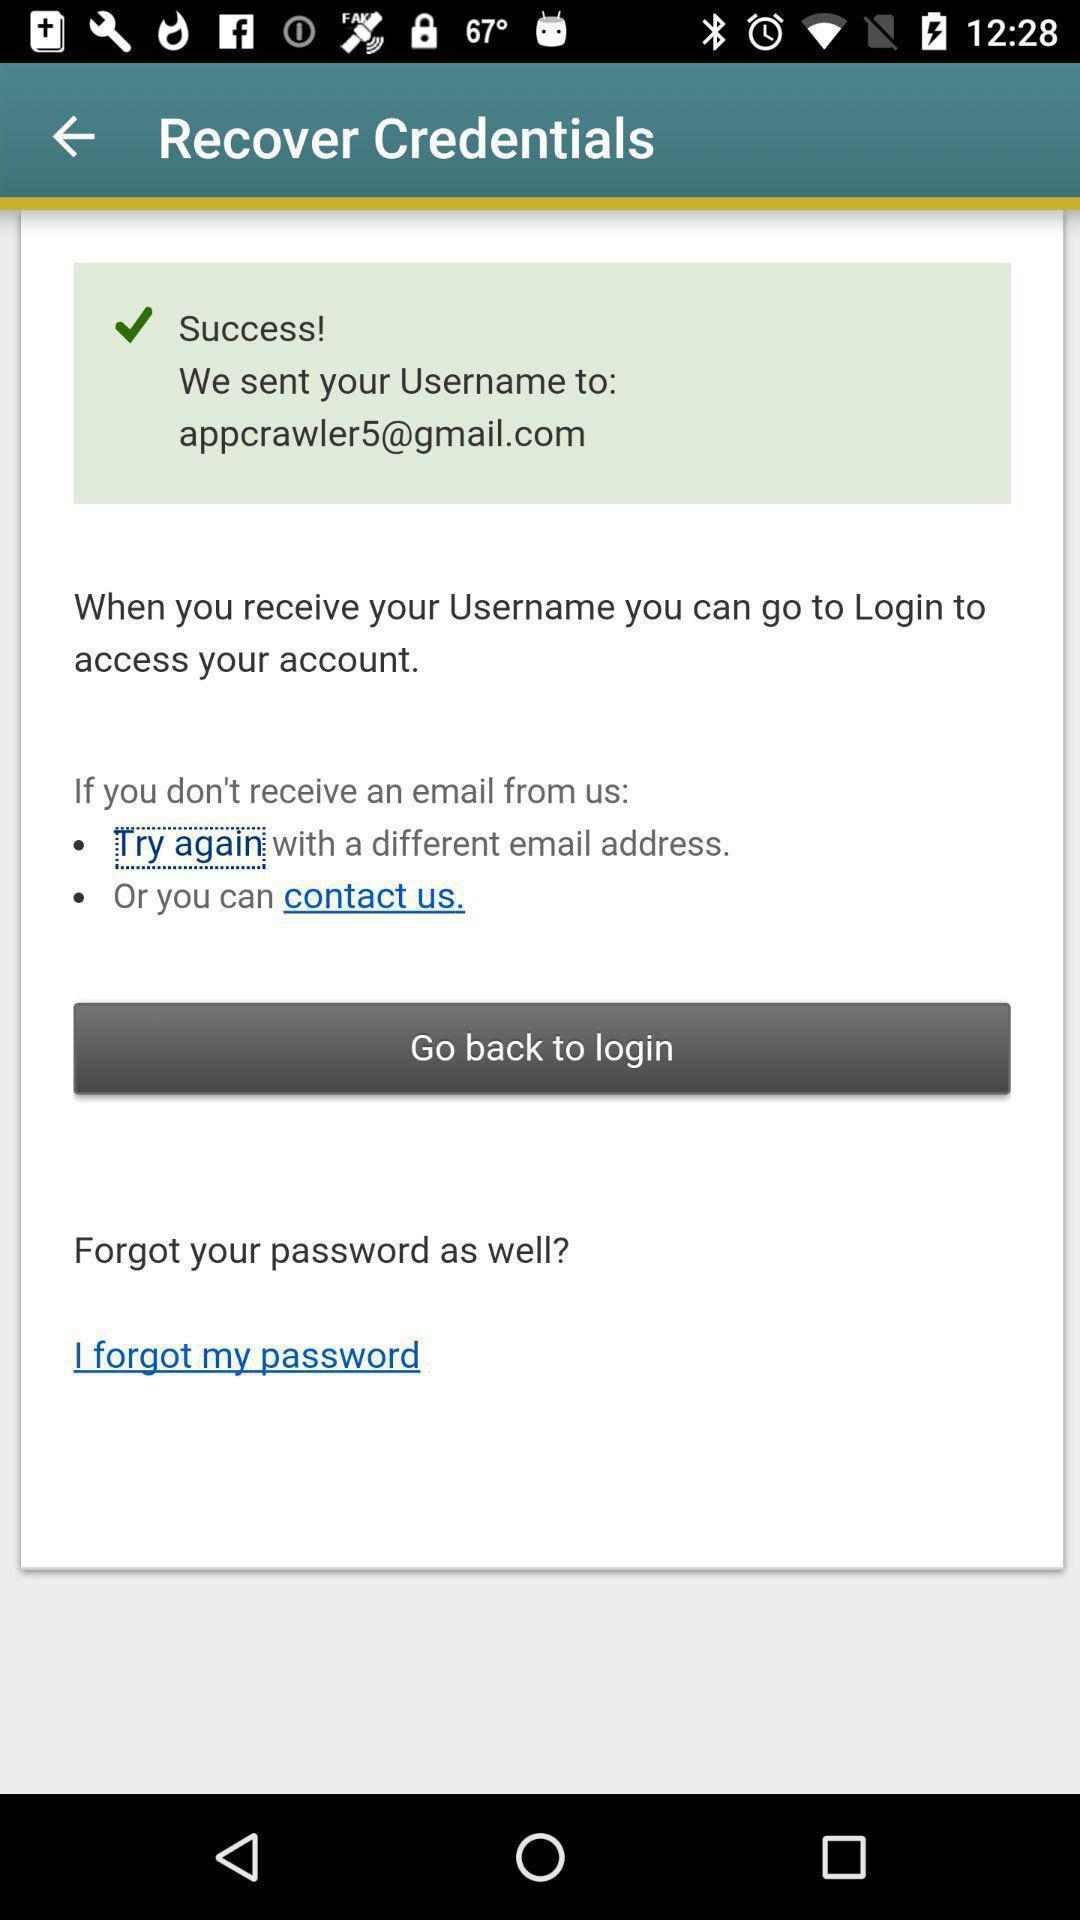What details can you identify in this image? Page showing success status for credentials recovery. 